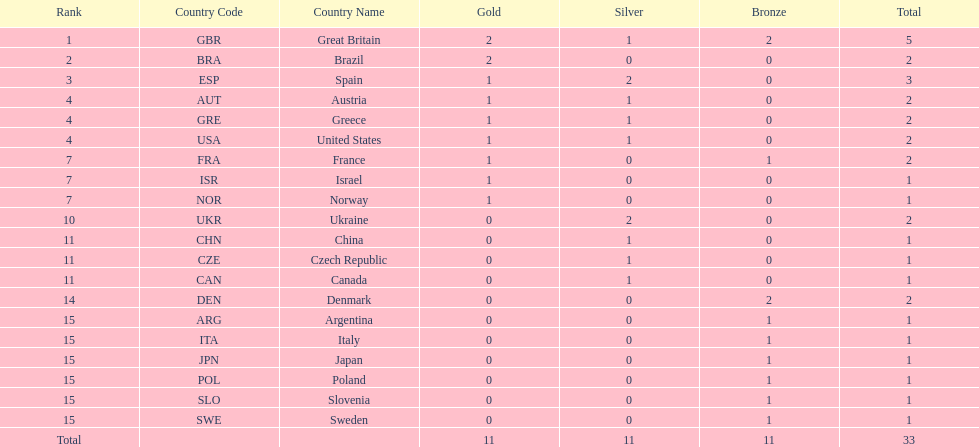How many countries won at least 2 medals in sailing? 9. 